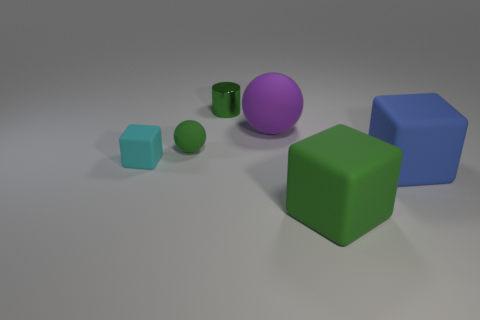Add 4 large shiny cubes. How many objects exist? 10 Subtract all spheres. How many objects are left? 4 Add 4 small balls. How many small balls exist? 5 Subtract 0 blue spheres. How many objects are left? 6 Subtract all big blocks. Subtract all green metallic objects. How many objects are left? 3 Add 3 large blue rubber things. How many large blue rubber things are left? 4 